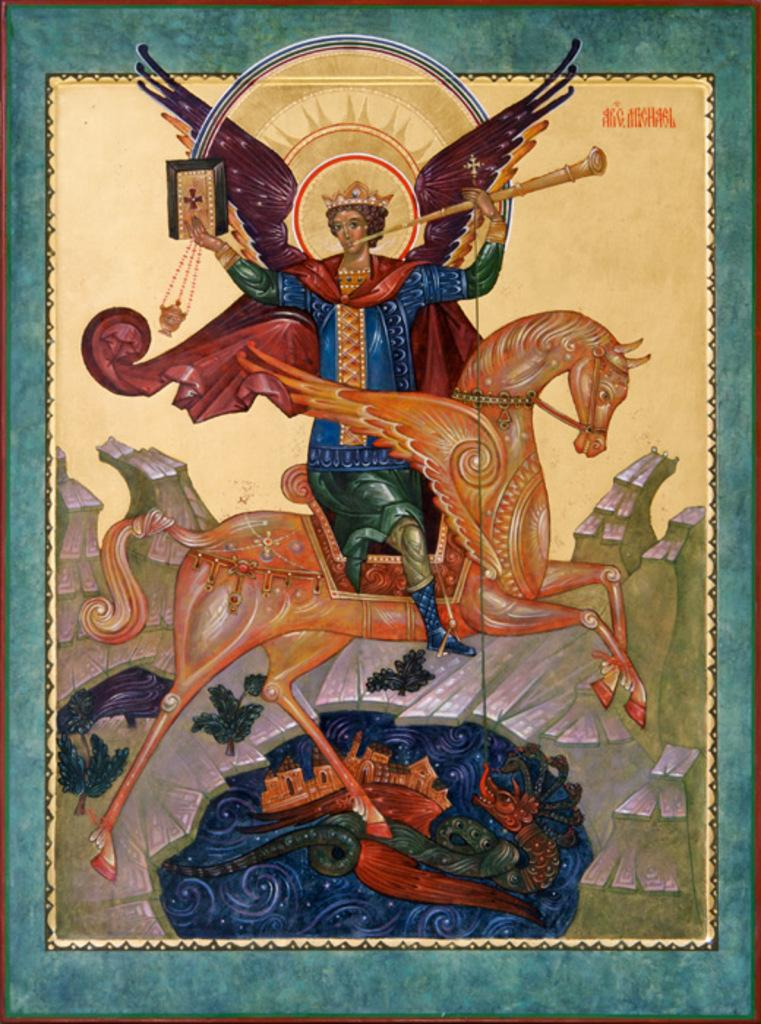What is the main object or feature in the image? There is a wall hanging in the image. Can you describe the wall hanging in more detail? Unfortunately, the provided facts do not give any additional details about the wall hanging. Is there anything else in the image besides the wall hanging? The given facts do not mention any other objects or features in the image. How does the wall hanging contribute to the increase in pollution in the image? There is no mention of pollution in the image, and the wall hanging does not have any direct impact on pollution levels. 